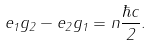Convert formula to latex. <formula><loc_0><loc_0><loc_500><loc_500>e _ { 1 } g _ { 2 } - e _ { 2 } g _ { 1 } = n \frac { \hbar { c } } 2 .</formula> 